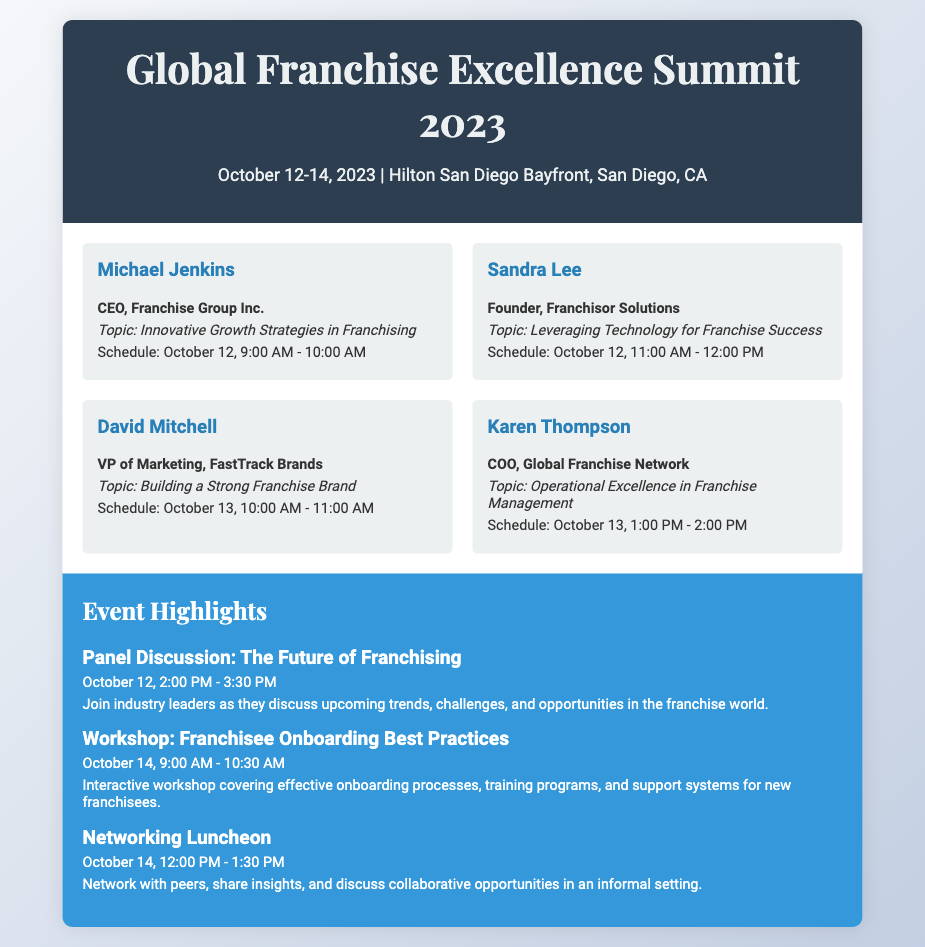What is the date of the conference? The conference is scheduled for October 12-14, 2023.
Answer: October 12-14, 2023 Who is the speaker presenting on October 12 at 9:00 AM? This speaker is Michael Jenkins, presenting on "Innovative Growth Strategies in Franchising."
Answer: Michael Jenkins What topic will Sandra Lee cover? Sandra Lee will present on "Leveraging Technology for Franchise Success."
Answer: Leveraging Technology for Franchise Success How many speakers are listed in the document? There are four speakers mentioned in the document.
Answer: Four What is the time for the panel discussion? The panel discussion is scheduled for October 12, from 2:00 PM to 3:30 PM.
Answer: October 12, 2:00 PM - 3:30 PM Which speaker is the COO of Global Franchise Network? The COO of Global Franchise Network is Karen Thompson.
Answer: Karen Thompson What is the title of the workshop on October 14? The workshop on October 14 is titled "Franchisee Onboarding Best Practices."
Answer: Franchisee Onboarding Best Practices What event occurs after the panel discussion on October 12? The event that occurs after the panel discussion is the Networking Luncheon on October 14.
Answer: Networking Luncheon When does David Mitchell's presentation start? David Mitchell's presentation starts on October 13 at 10:00 AM.
Answer: October 13, 10:00 AM 